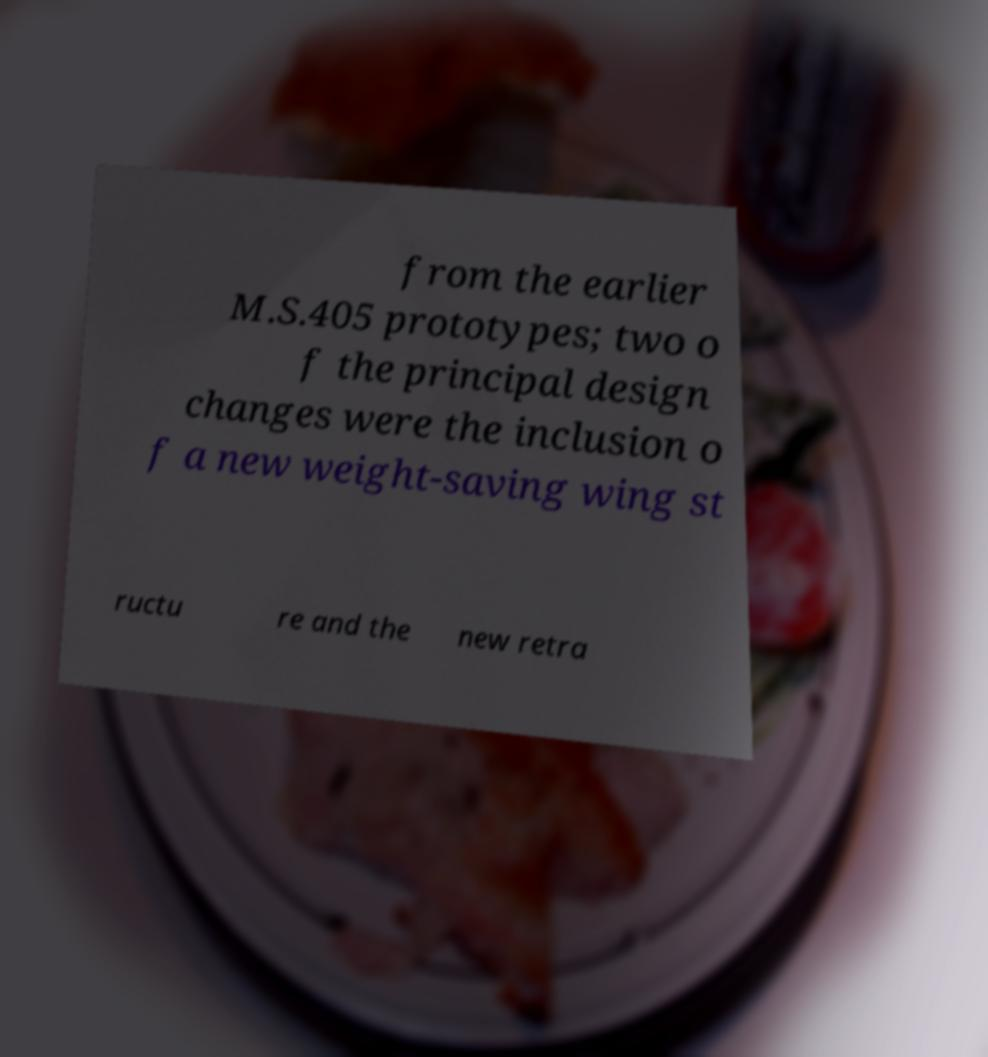Could you extract and type out the text from this image? from the earlier M.S.405 prototypes; two o f the principal design changes were the inclusion o f a new weight-saving wing st ructu re and the new retra 